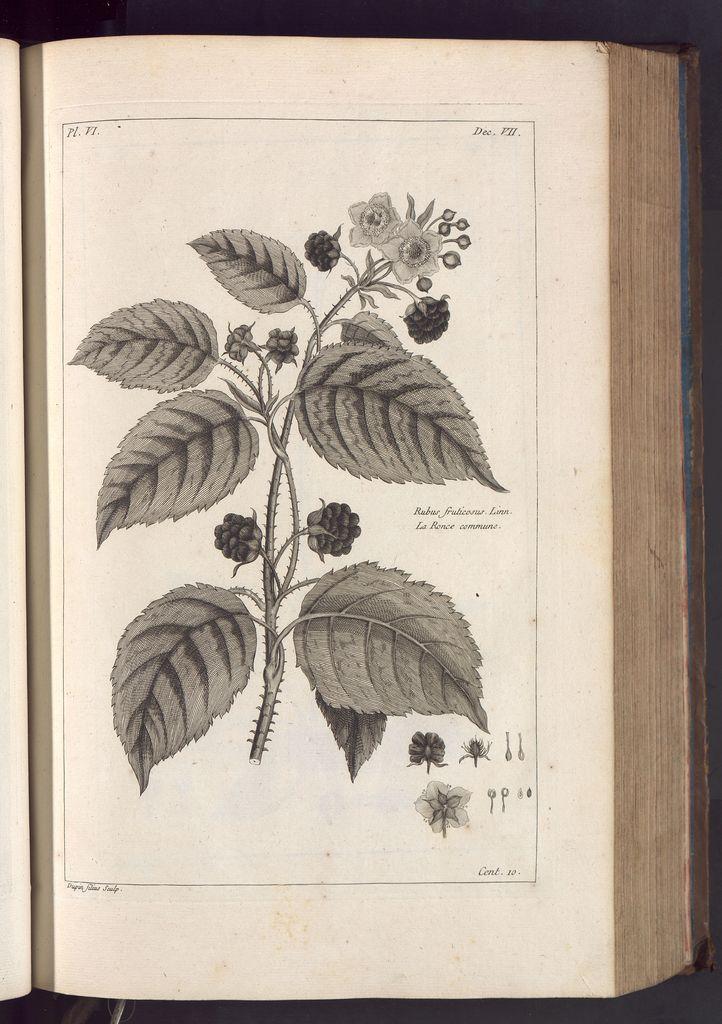Could you give a brief overview of what you see in this image? In this picture we can see an open book. We can see a few leaves, flowers, stems, some text and a few things on this open book. 